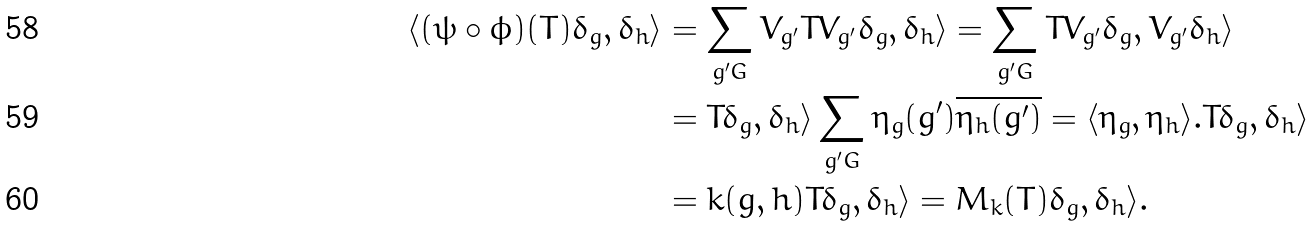<formula> <loc_0><loc_0><loc_500><loc_500>\langle ( \psi \circ \phi ) ( T ) \delta _ { g } , \delta _ { h } \rangle & = \sum _ { g ^ { \prime } G } V _ { g ^ { \prime } } T V _ { g ^ { \prime } } \delta _ { g } , \delta _ { h } \rangle = \sum _ { g ^ { \prime } G } T V _ { g ^ { \prime } } \delta _ { g } , V _ { g ^ { \prime } } \delta _ { h } \rangle \\ & = T \delta _ { g } , \delta _ { h } \rangle \sum _ { g ^ { \prime } G } \eta _ { g } ( g ^ { \prime } ) \overline { \eta _ { h } ( g ^ { \prime } ) } = \langle \eta _ { g } , \eta _ { h } \rangle . T \delta _ { g } , \delta _ { h } \rangle \\ & = k ( g , h ) T \delta _ { g } , \delta _ { h } \rangle = M _ { k } ( T ) \delta _ { g } , \delta _ { h } \rangle .</formula> 